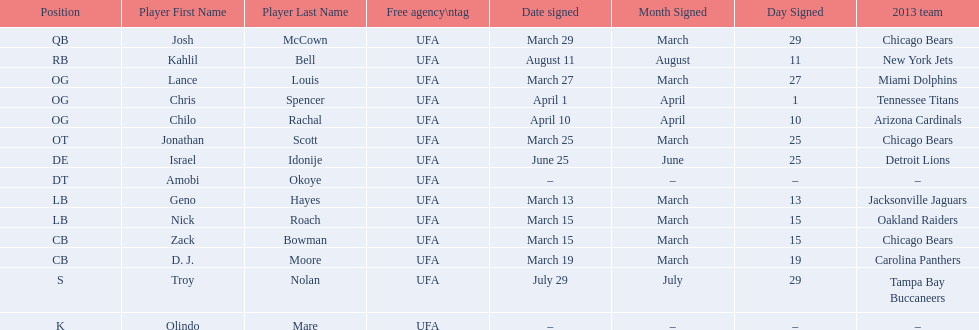How many players were signed in march? 7. 